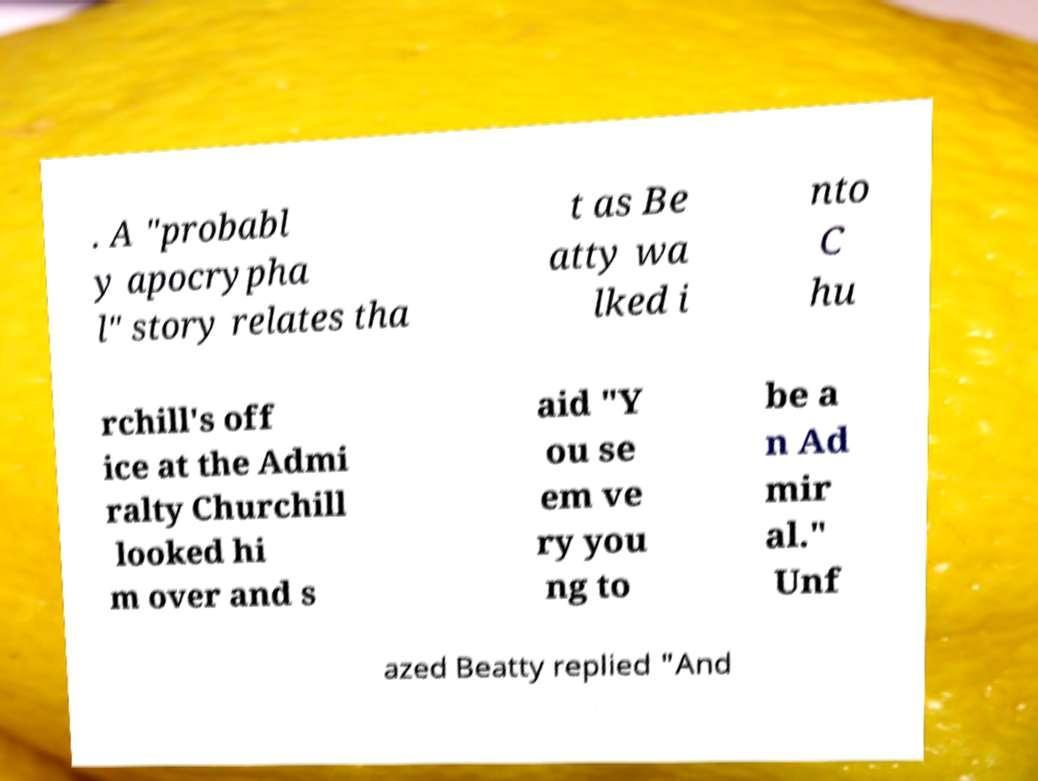Could you extract and type out the text from this image? . A "probabl y apocrypha l" story relates tha t as Be atty wa lked i nto C hu rchill's off ice at the Admi ralty Churchill looked hi m over and s aid "Y ou se em ve ry you ng to be a n Ad mir al." Unf azed Beatty replied "And 